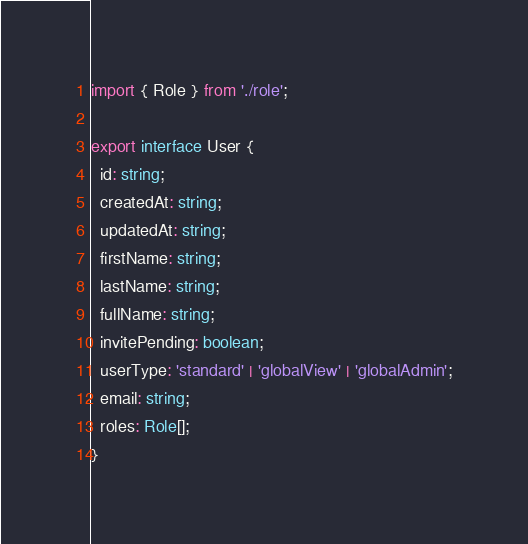Convert code to text. <code><loc_0><loc_0><loc_500><loc_500><_TypeScript_>import { Role } from './role';

export interface User {
  id: string;
  createdAt: string;
  updatedAt: string;
  firstName: string;
  lastName: string;
  fullName: string;
  invitePending: boolean;
  userType: 'standard' | 'globalView' | 'globalAdmin';
  email: string;
  roles: Role[];
}
</code> 